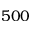Convert formula to latex. <formula><loc_0><loc_0><loc_500><loc_500>5 0 0</formula> 